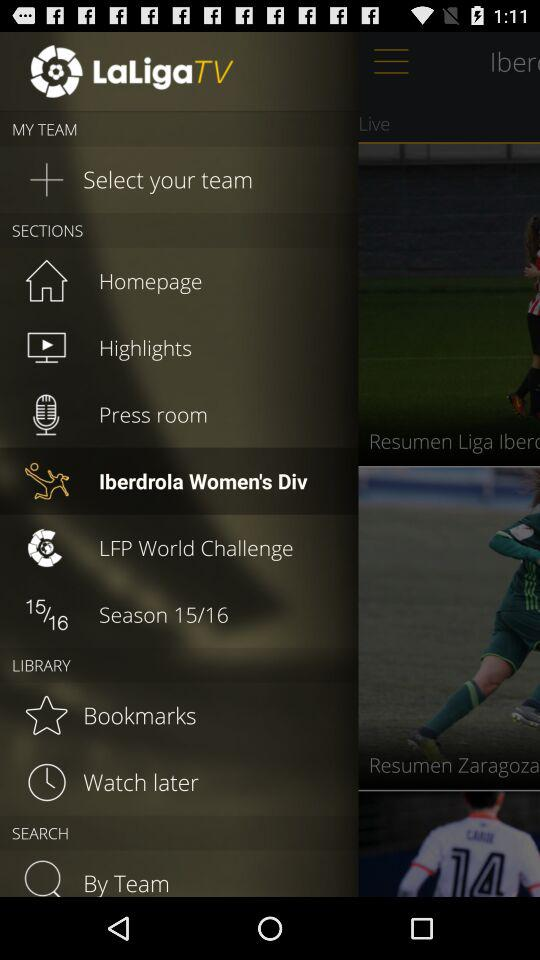What's the selected item in "SECTIONS"? The selected item in "SECTIONS" is "Iberdrola Women's Div". 